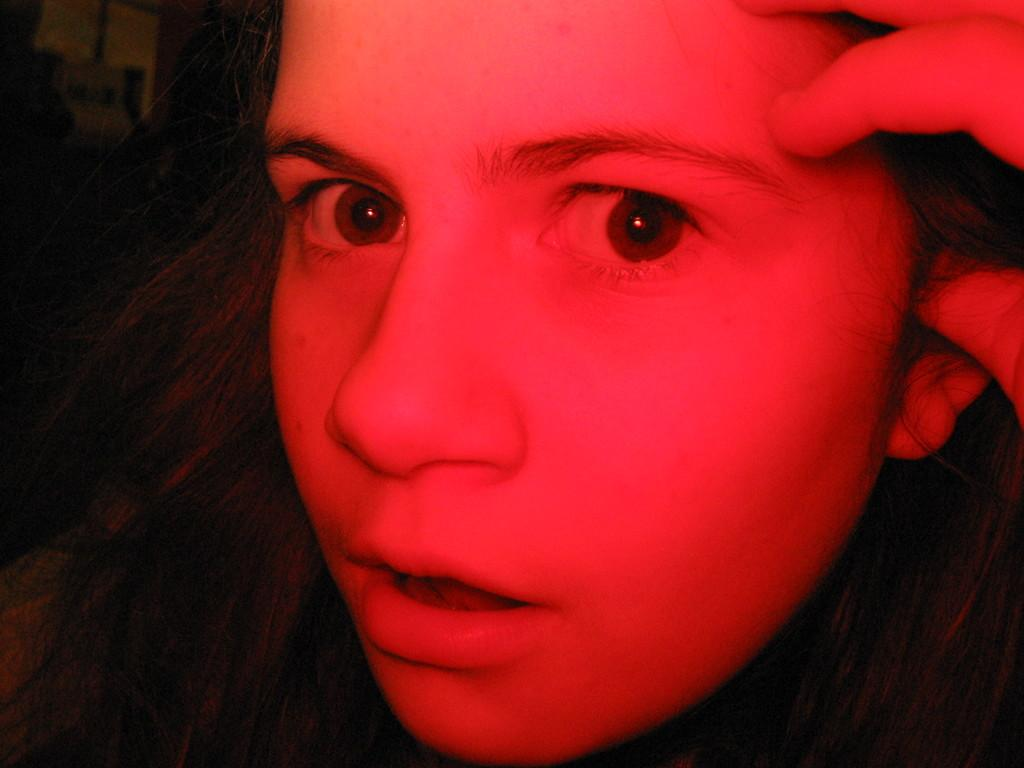What can be observed about the image's appearance? The image appears to be edited. What is the main subject in the image? There is a woman's head in the image. How would you describe the background of the image? The background of the image is dark. Can you see any harbors in the image? There are no harbors present in the image. What type of pickle is being used as a prop in the image? There is no pickle present in the image. 